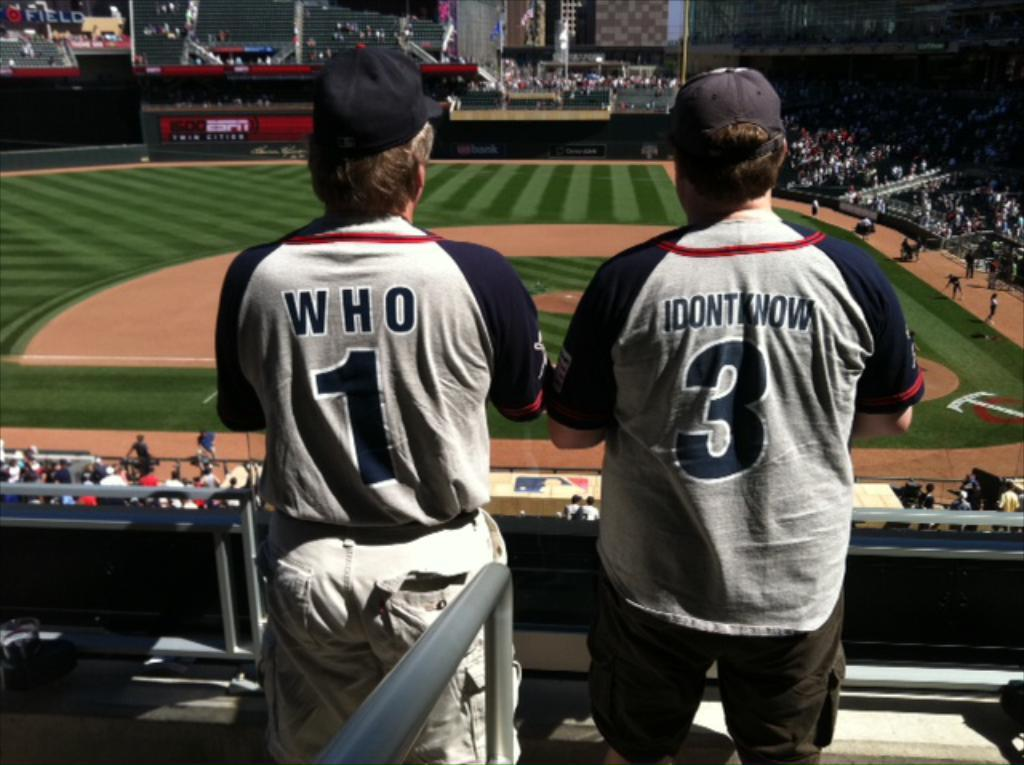<image>
Summarize the visual content of the image. two people in jerseys reading Who and I Don't Know watch a baseball game 